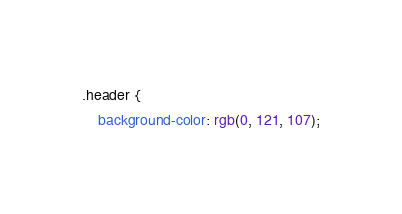<code> <loc_0><loc_0><loc_500><loc_500><_CSS_>.header {
    background-color: rgb(0, 121, 107);</code> 